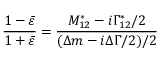<formula> <loc_0><loc_0><loc_500><loc_500>\frac { 1 - \bar { \varepsilon } } { 1 + \bar { \varepsilon } } = \frac { M _ { 1 2 } ^ { * } - i \Gamma _ { 1 2 } ^ { * } / 2 } { ( \Delta m - i \Delta \Gamma / 2 ) / 2 }</formula> 